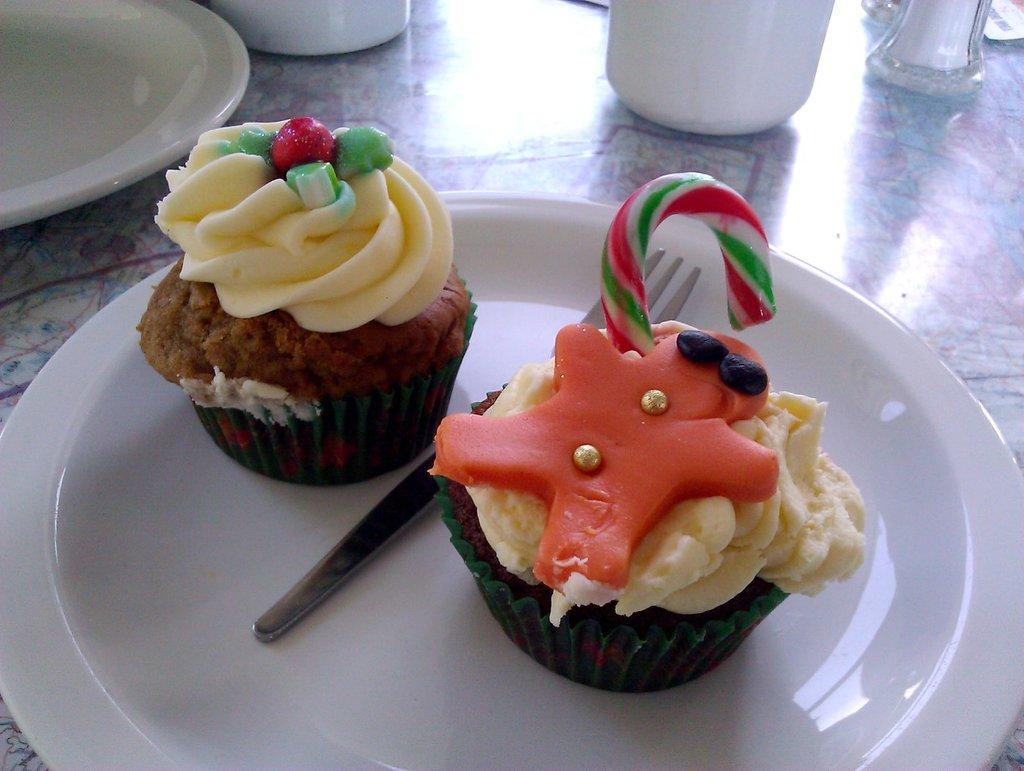What type of dessert is on the plate in the image? There are two cupcakes on a plate in the image. Are there any other plates visible in the image? Yes, there is another plate in the image. What else can be seen on the table in the image? There are other objects on the table in the image. What type of meat is being served on the square plate in the image? There is no meat or square plate present in the image; it only features cupcakes on a plate and another plate. 